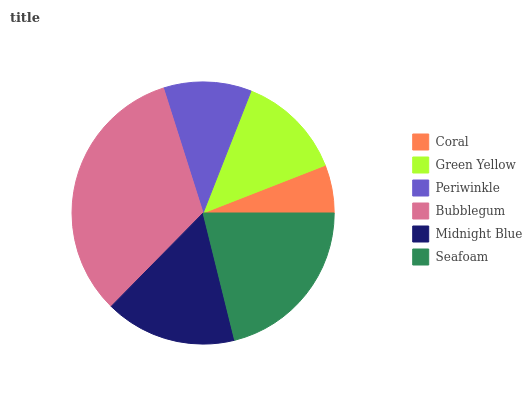Is Coral the minimum?
Answer yes or no. Yes. Is Bubblegum the maximum?
Answer yes or no. Yes. Is Green Yellow the minimum?
Answer yes or no. No. Is Green Yellow the maximum?
Answer yes or no. No. Is Green Yellow greater than Coral?
Answer yes or no. Yes. Is Coral less than Green Yellow?
Answer yes or no. Yes. Is Coral greater than Green Yellow?
Answer yes or no. No. Is Green Yellow less than Coral?
Answer yes or no. No. Is Midnight Blue the high median?
Answer yes or no. Yes. Is Green Yellow the low median?
Answer yes or no. Yes. Is Bubblegum the high median?
Answer yes or no. No. Is Coral the low median?
Answer yes or no. No. 